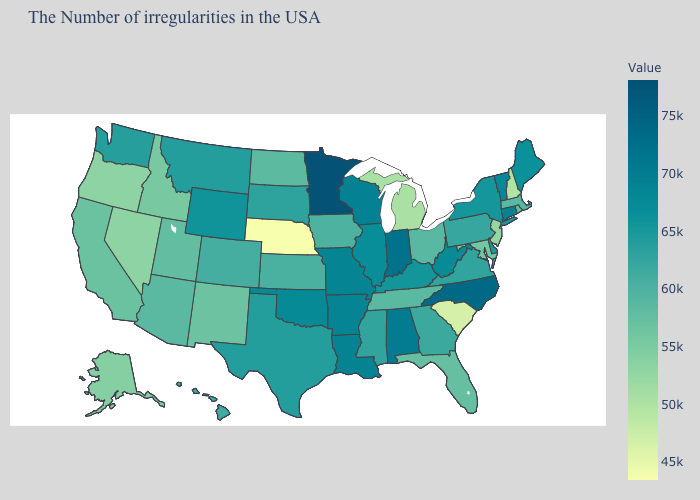Among the states that border West Virginia , which have the highest value?
Write a very short answer. Kentucky. Is the legend a continuous bar?
Keep it brief. Yes. Does the map have missing data?
Write a very short answer. No. Among the states that border Wyoming , does South Dakota have the highest value?
Answer briefly. No. Does Oregon have a higher value than New Hampshire?
Keep it brief. Yes. Among the states that border California , which have the lowest value?
Short answer required. Oregon. Does Delaware have a lower value than Michigan?
Answer briefly. No. 